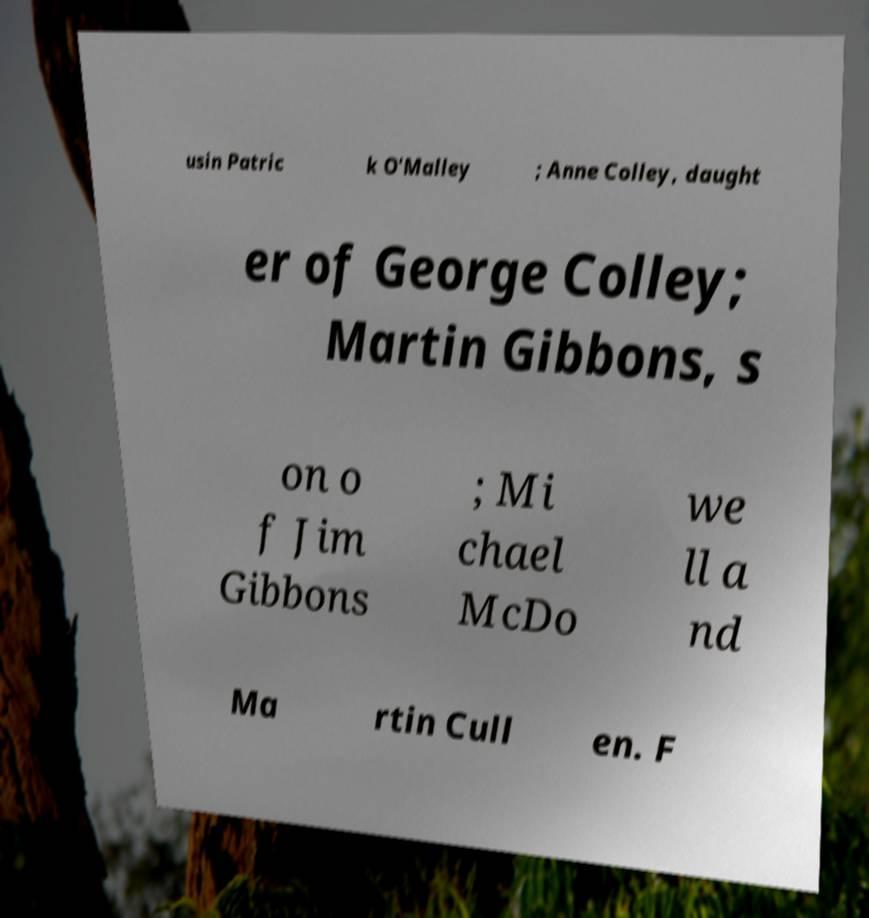Could you extract and type out the text from this image? usin Patric k O'Malley ; Anne Colley, daught er of George Colley; Martin Gibbons, s on o f Jim Gibbons ; Mi chael McDo we ll a nd Ma rtin Cull en. F 